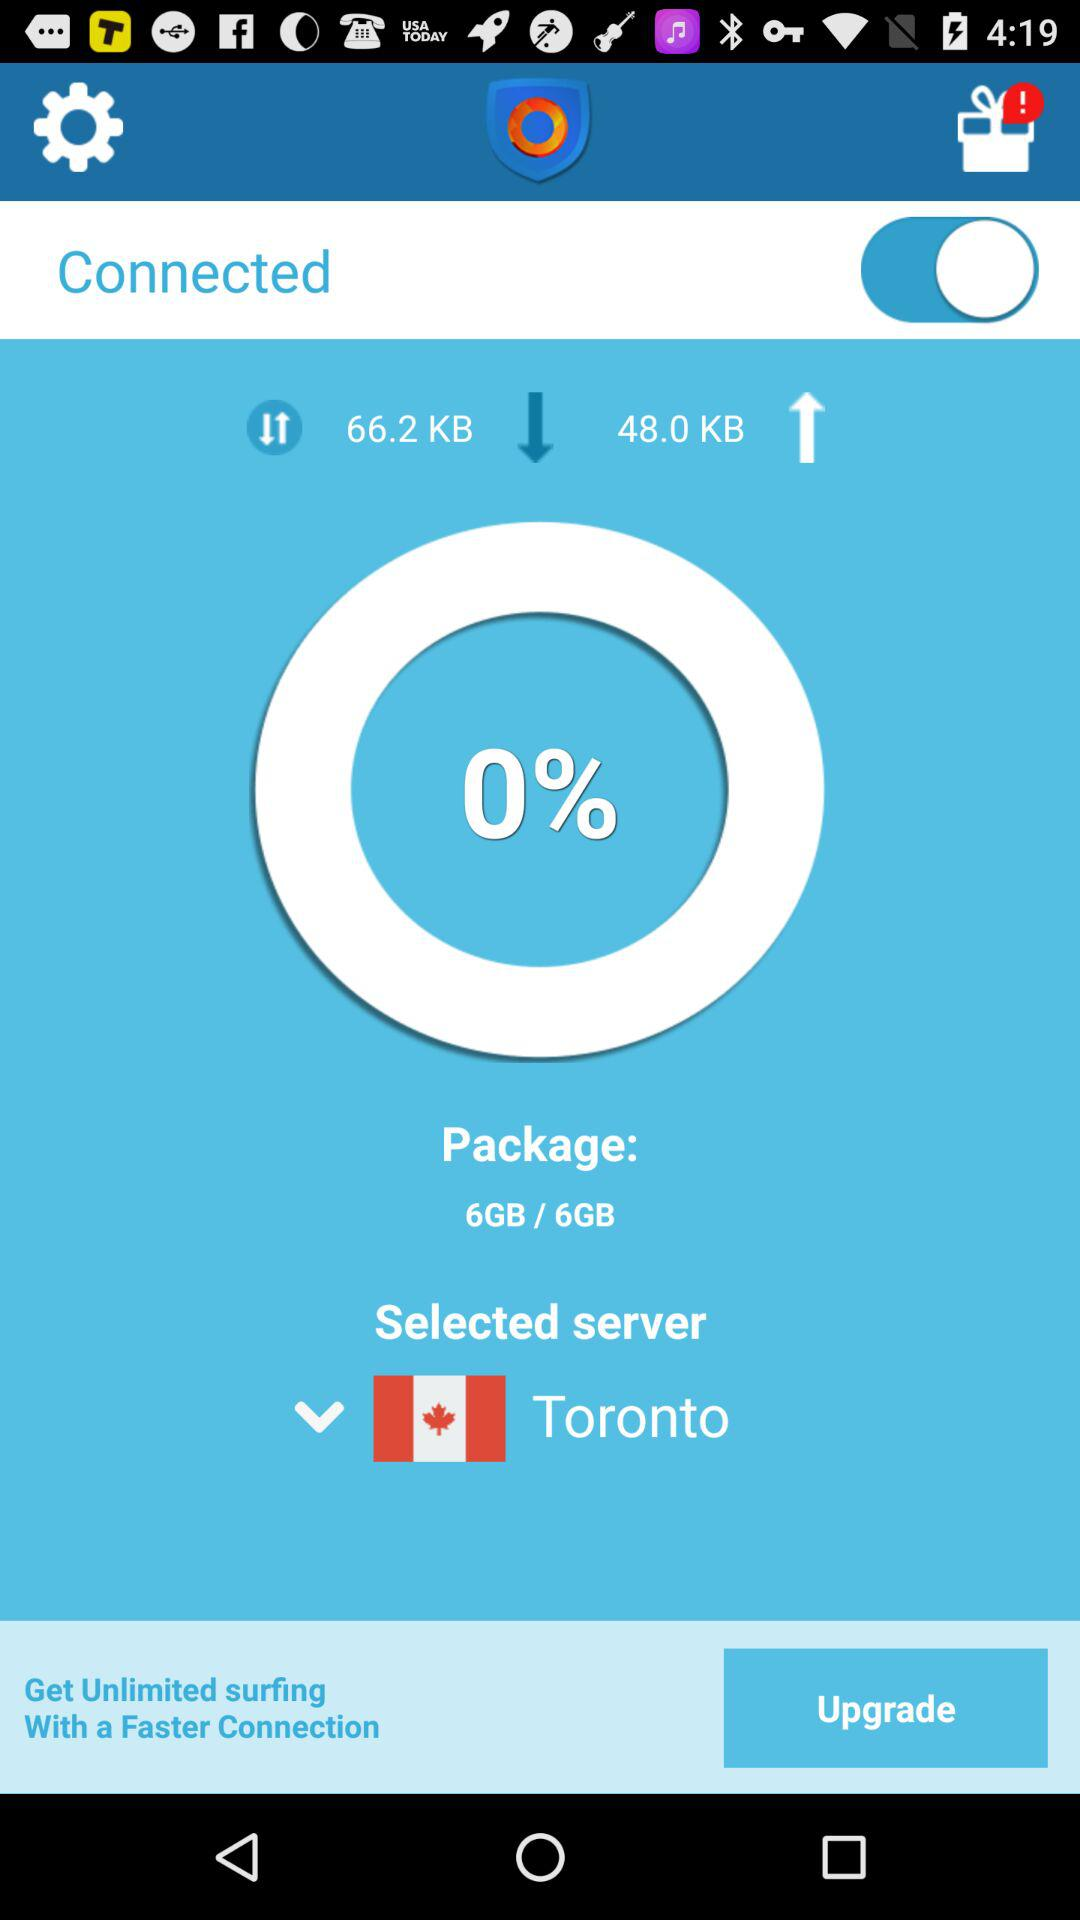What is the percentage of my data usage for this month?
Answer the question using a single word or phrase. 0% 